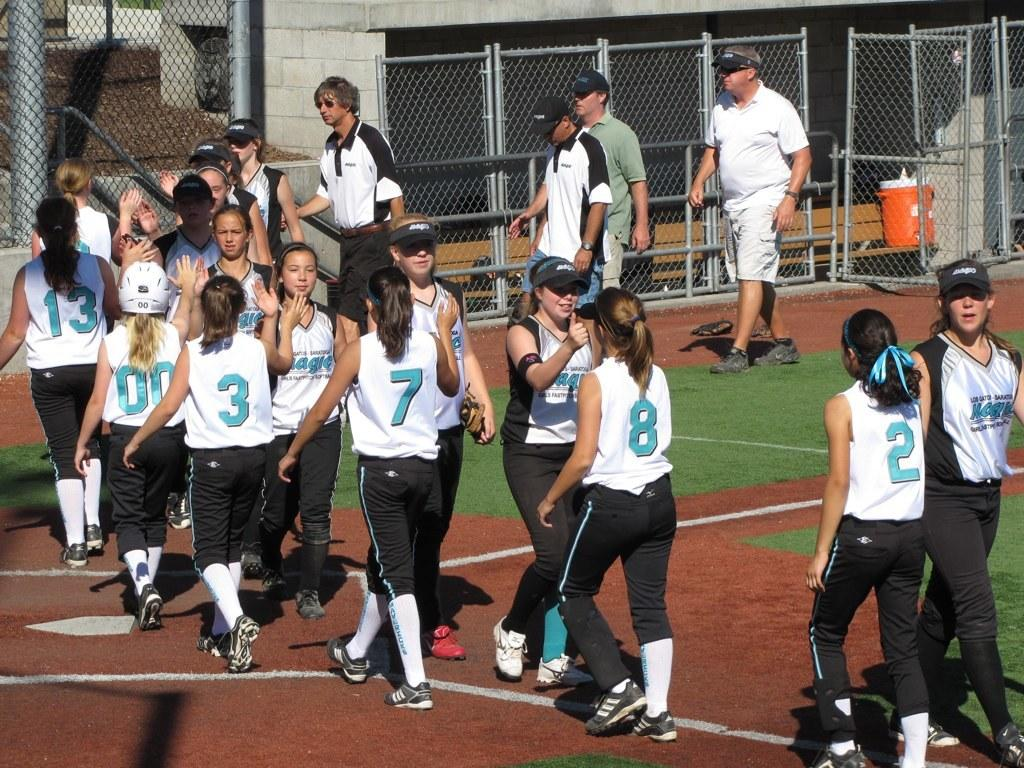What is happening with the people in the image? There are people on the ground in the image. What can be seen in the background of the image? There is a fence and a wall visible in the background of the image. Can you describe any objects in the image? There appears to be a bottle in the image. What type of beast is controlling the rainstorm in the image? There is no beast or rainstorm present in the image. 